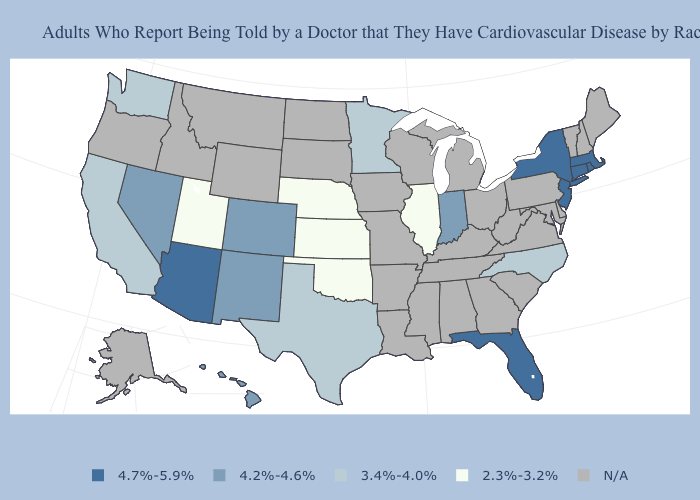Does Utah have the lowest value in the West?
Answer briefly. Yes. Name the states that have a value in the range 4.7%-5.9%?
Quick response, please. Arizona, Connecticut, Florida, Massachusetts, New Jersey, New York, Rhode Island. Which states have the lowest value in the USA?
Write a very short answer. Illinois, Kansas, Nebraska, Oklahoma, Utah. What is the lowest value in the USA?
Answer briefly. 2.3%-3.2%. Which states have the lowest value in the USA?
Give a very brief answer. Illinois, Kansas, Nebraska, Oklahoma, Utah. Name the states that have a value in the range 3.4%-4.0%?
Quick response, please. California, Minnesota, North Carolina, Texas, Washington. Name the states that have a value in the range N/A?
Concise answer only. Alabama, Alaska, Arkansas, Delaware, Georgia, Idaho, Iowa, Kentucky, Louisiana, Maine, Maryland, Michigan, Mississippi, Missouri, Montana, New Hampshire, North Dakota, Ohio, Oregon, Pennsylvania, South Carolina, South Dakota, Tennessee, Vermont, Virginia, West Virginia, Wisconsin, Wyoming. What is the value of Colorado?
Concise answer only. 4.2%-4.6%. Does Colorado have the lowest value in the USA?
Quick response, please. No. Which states hav the highest value in the Northeast?
Answer briefly. Connecticut, Massachusetts, New Jersey, New York, Rhode Island. 